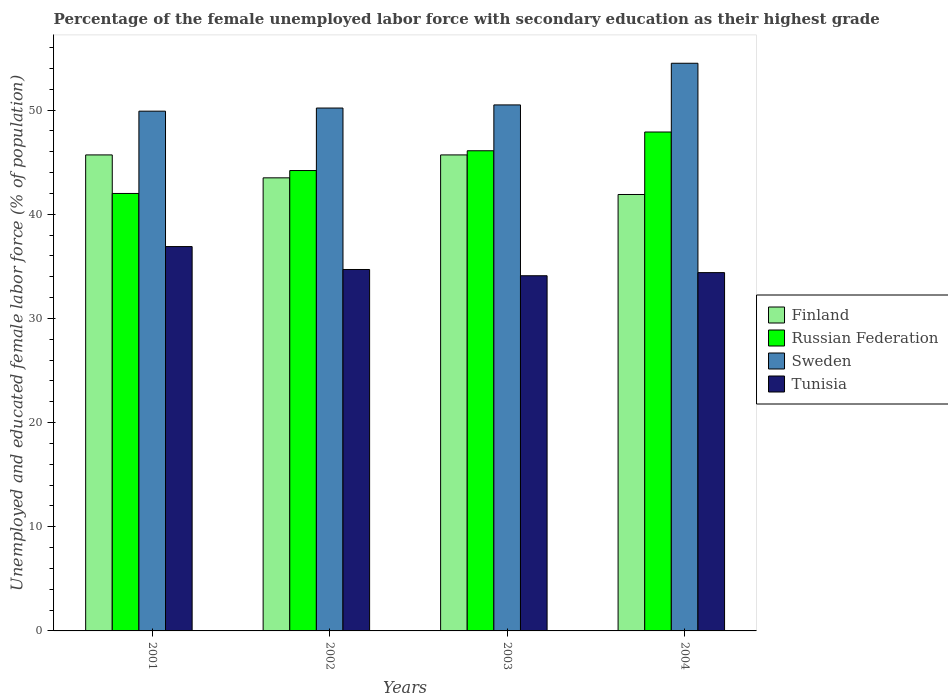How many different coloured bars are there?
Give a very brief answer. 4. How many bars are there on the 2nd tick from the left?
Offer a very short reply. 4. How many bars are there on the 3rd tick from the right?
Your answer should be compact. 4. What is the label of the 1st group of bars from the left?
Your response must be concise. 2001. What is the percentage of the unemployed female labor force with secondary education in Russian Federation in 2004?
Offer a terse response. 47.9. Across all years, what is the maximum percentage of the unemployed female labor force with secondary education in Sweden?
Ensure brevity in your answer.  54.5. Across all years, what is the minimum percentage of the unemployed female labor force with secondary education in Tunisia?
Provide a succinct answer. 34.1. In which year was the percentage of the unemployed female labor force with secondary education in Sweden maximum?
Your answer should be very brief. 2004. What is the total percentage of the unemployed female labor force with secondary education in Finland in the graph?
Make the answer very short. 176.8. What is the difference between the percentage of the unemployed female labor force with secondary education in Sweden in 2001 and that in 2003?
Offer a terse response. -0.6. What is the difference between the percentage of the unemployed female labor force with secondary education in Finland in 2003 and the percentage of the unemployed female labor force with secondary education in Russian Federation in 2004?
Give a very brief answer. -2.2. What is the average percentage of the unemployed female labor force with secondary education in Sweden per year?
Make the answer very short. 51.28. What is the ratio of the percentage of the unemployed female labor force with secondary education in Sweden in 2001 to that in 2004?
Your response must be concise. 0.92. Is the percentage of the unemployed female labor force with secondary education in Tunisia in 2002 less than that in 2004?
Provide a succinct answer. No. Is the difference between the percentage of the unemployed female labor force with secondary education in Russian Federation in 2003 and 2004 greater than the difference between the percentage of the unemployed female labor force with secondary education in Finland in 2003 and 2004?
Provide a succinct answer. No. What is the difference between the highest and the second highest percentage of the unemployed female labor force with secondary education in Russian Federation?
Make the answer very short. 1.8. What is the difference between the highest and the lowest percentage of the unemployed female labor force with secondary education in Tunisia?
Your answer should be compact. 2.8. In how many years, is the percentage of the unemployed female labor force with secondary education in Tunisia greater than the average percentage of the unemployed female labor force with secondary education in Tunisia taken over all years?
Your answer should be compact. 1. Is it the case that in every year, the sum of the percentage of the unemployed female labor force with secondary education in Finland and percentage of the unemployed female labor force with secondary education in Tunisia is greater than the sum of percentage of the unemployed female labor force with secondary education in Sweden and percentage of the unemployed female labor force with secondary education in Russian Federation?
Make the answer very short. No. How many bars are there?
Offer a very short reply. 16. Are all the bars in the graph horizontal?
Your answer should be compact. No. What is the difference between two consecutive major ticks on the Y-axis?
Offer a terse response. 10. Does the graph contain any zero values?
Keep it short and to the point. No. How are the legend labels stacked?
Give a very brief answer. Vertical. What is the title of the graph?
Offer a terse response. Percentage of the female unemployed labor force with secondary education as their highest grade. What is the label or title of the X-axis?
Your response must be concise. Years. What is the label or title of the Y-axis?
Your answer should be compact. Unemployed and educated female labor force (% of population). What is the Unemployed and educated female labor force (% of population) of Finland in 2001?
Give a very brief answer. 45.7. What is the Unemployed and educated female labor force (% of population) of Sweden in 2001?
Offer a very short reply. 49.9. What is the Unemployed and educated female labor force (% of population) in Tunisia in 2001?
Your answer should be very brief. 36.9. What is the Unemployed and educated female labor force (% of population) of Finland in 2002?
Provide a succinct answer. 43.5. What is the Unemployed and educated female labor force (% of population) in Russian Federation in 2002?
Make the answer very short. 44.2. What is the Unemployed and educated female labor force (% of population) in Sweden in 2002?
Offer a very short reply. 50.2. What is the Unemployed and educated female labor force (% of population) of Tunisia in 2002?
Give a very brief answer. 34.7. What is the Unemployed and educated female labor force (% of population) in Finland in 2003?
Your answer should be very brief. 45.7. What is the Unemployed and educated female labor force (% of population) in Russian Federation in 2003?
Your answer should be very brief. 46.1. What is the Unemployed and educated female labor force (% of population) in Sweden in 2003?
Your answer should be very brief. 50.5. What is the Unemployed and educated female labor force (% of population) of Tunisia in 2003?
Provide a succinct answer. 34.1. What is the Unemployed and educated female labor force (% of population) of Finland in 2004?
Provide a short and direct response. 41.9. What is the Unemployed and educated female labor force (% of population) in Russian Federation in 2004?
Keep it short and to the point. 47.9. What is the Unemployed and educated female labor force (% of population) of Sweden in 2004?
Give a very brief answer. 54.5. What is the Unemployed and educated female labor force (% of population) of Tunisia in 2004?
Give a very brief answer. 34.4. Across all years, what is the maximum Unemployed and educated female labor force (% of population) of Finland?
Provide a succinct answer. 45.7. Across all years, what is the maximum Unemployed and educated female labor force (% of population) in Russian Federation?
Your answer should be very brief. 47.9. Across all years, what is the maximum Unemployed and educated female labor force (% of population) of Sweden?
Give a very brief answer. 54.5. Across all years, what is the maximum Unemployed and educated female labor force (% of population) in Tunisia?
Provide a short and direct response. 36.9. Across all years, what is the minimum Unemployed and educated female labor force (% of population) of Finland?
Ensure brevity in your answer.  41.9. Across all years, what is the minimum Unemployed and educated female labor force (% of population) of Russian Federation?
Make the answer very short. 42. Across all years, what is the minimum Unemployed and educated female labor force (% of population) of Sweden?
Offer a very short reply. 49.9. Across all years, what is the minimum Unemployed and educated female labor force (% of population) of Tunisia?
Give a very brief answer. 34.1. What is the total Unemployed and educated female labor force (% of population) of Finland in the graph?
Offer a very short reply. 176.8. What is the total Unemployed and educated female labor force (% of population) in Russian Federation in the graph?
Provide a succinct answer. 180.2. What is the total Unemployed and educated female labor force (% of population) of Sweden in the graph?
Give a very brief answer. 205.1. What is the total Unemployed and educated female labor force (% of population) of Tunisia in the graph?
Ensure brevity in your answer.  140.1. What is the difference between the Unemployed and educated female labor force (% of population) in Finland in 2001 and that in 2002?
Provide a short and direct response. 2.2. What is the difference between the Unemployed and educated female labor force (% of population) of Russian Federation in 2001 and that in 2002?
Offer a very short reply. -2.2. What is the difference between the Unemployed and educated female labor force (% of population) of Finland in 2001 and that in 2003?
Your answer should be compact. 0. What is the difference between the Unemployed and educated female labor force (% of population) of Russian Federation in 2001 and that in 2003?
Your answer should be very brief. -4.1. What is the difference between the Unemployed and educated female labor force (% of population) of Sweden in 2001 and that in 2003?
Provide a short and direct response. -0.6. What is the difference between the Unemployed and educated female labor force (% of population) in Russian Federation in 2001 and that in 2004?
Keep it short and to the point. -5.9. What is the difference between the Unemployed and educated female labor force (% of population) of Sweden in 2001 and that in 2004?
Your answer should be very brief. -4.6. What is the difference between the Unemployed and educated female labor force (% of population) of Tunisia in 2001 and that in 2004?
Give a very brief answer. 2.5. What is the difference between the Unemployed and educated female labor force (% of population) in Finland in 2002 and that in 2003?
Ensure brevity in your answer.  -2.2. What is the difference between the Unemployed and educated female labor force (% of population) of Russian Federation in 2002 and that in 2003?
Give a very brief answer. -1.9. What is the difference between the Unemployed and educated female labor force (% of population) in Russian Federation in 2002 and that in 2004?
Your answer should be very brief. -3.7. What is the difference between the Unemployed and educated female labor force (% of population) in Tunisia in 2002 and that in 2004?
Your answer should be compact. 0.3. What is the difference between the Unemployed and educated female labor force (% of population) of Finland in 2001 and the Unemployed and educated female labor force (% of population) of Russian Federation in 2002?
Provide a short and direct response. 1.5. What is the difference between the Unemployed and educated female labor force (% of population) in Finland in 2001 and the Unemployed and educated female labor force (% of population) in Sweden in 2002?
Provide a short and direct response. -4.5. What is the difference between the Unemployed and educated female labor force (% of population) of Finland in 2001 and the Unemployed and educated female labor force (% of population) of Tunisia in 2002?
Your answer should be very brief. 11. What is the difference between the Unemployed and educated female labor force (% of population) of Russian Federation in 2001 and the Unemployed and educated female labor force (% of population) of Sweden in 2002?
Make the answer very short. -8.2. What is the difference between the Unemployed and educated female labor force (% of population) in Russian Federation in 2001 and the Unemployed and educated female labor force (% of population) in Tunisia in 2002?
Your answer should be very brief. 7.3. What is the difference between the Unemployed and educated female labor force (% of population) of Finland in 2001 and the Unemployed and educated female labor force (% of population) of Sweden in 2003?
Provide a succinct answer. -4.8. What is the difference between the Unemployed and educated female labor force (% of population) in Russian Federation in 2001 and the Unemployed and educated female labor force (% of population) in Sweden in 2003?
Ensure brevity in your answer.  -8.5. What is the difference between the Unemployed and educated female labor force (% of population) in Russian Federation in 2001 and the Unemployed and educated female labor force (% of population) in Tunisia in 2003?
Your response must be concise. 7.9. What is the difference between the Unemployed and educated female labor force (% of population) in Sweden in 2001 and the Unemployed and educated female labor force (% of population) in Tunisia in 2003?
Your answer should be compact. 15.8. What is the difference between the Unemployed and educated female labor force (% of population) in Finland in 2001 and the Unemployed and educated female labor force (% of population) in Sweden in 2004?
Ensure brevity in your answer.  -8.8. What is the difference between the Unemployed and educated female labor force (% of population) of Finland in 2001 and the Unemployed and educated female labor force (% of population) of Tunisia in 2004?
Your answer should be compact. 11.3. What is the difference between the Unemployed and educated female labor force (% of population) of Finland in 2002 and the Unemployed and educated female labor force (% of population) of Tunisia in 2003?
Ensure brevity in your answer.  9.4. What is the difference between the Unemployed and educated female labor force (% of population) in Russian Federation in 2002 and the Unemployed and educated female labor force (% of population) in Sweden in 2003?
Ensure brevity in your answer.  -6.3. What is the difference between the Unemployed and educated female labor force (% of population) of Russian Federation in 2002 and the Unemployed and educated female labor force (% of population) of Tunisia in 2003?
Make the answer very short. 10.1. What is the difference between the Unemployed and educated female labor force (% of population) in Sweden in 2002 and the Unemployed and educated female labor force (% of population) in Tunisia in 2003?
Your answer should be very brief. 16.1. What is the difference between the Unemployed and educated female labor force (% of population) of Finland in 2002 and the Unemployed and educated female labor force (% of population) of Sweden in 2004?
Your answer should be very brief. -11. What is the difference between the Unemployed and educated female labor force (% of population) in Finland in 2002 and the Unemployed and educated female labor force (% of population) in Tunisia in 2004?
Provide a succinct answer. 9.1. What is the difference between the Unemployed and educated female labor force (% of population) in Russian Federation in 2002 and the Unemployed and educated female labor force (% of population) in Sweden in 2004?
Offer a terse response. -10.3. What is the difference between the Unemployed and educated female labor force (% of population) of Sweden in 2002 and the Unemployed and educated female labor force (% of population) of Tunisia in 2004?
Offer a very short reply. 15.8. What is the difference between the Unemployed and educated female labor force (% of population) of Finland in 2003 and the Unemployed and educated female labor force (% of population) of Tunisia in 2004?
Provide a short and direct response. 11.3. What is the average Unemployed and educated female labor force (% of population) in Finland per year?
Ensure brevity in your answer.  44.2. What is the average Unemployed and educated female labor force (% of population) in Russian Federation per year?
Offer a terse response. 45.05. What is the average Unemployed and educated female labor force (% of population) of Sweden per year?
Give a very brief answer. 51.27. What is the average Unemployed and educated female labor force (% of population) of Tunisia per year?
Your answer should be compact. 35.02. In the year 2001, what is the difference between the Unemployed and educated female labor force (% of population) in Finland and Unemployed and educated female labor force (% of population) in Russian Federation?
Your answer should be very brief. 3.7. In the year 2001, what is the difference between the Unemployed and educated female labor force (% of population) of Finland and Unemployed and educated female labor force (% of population) of Tunisia?
Your answer should be compact. 8.8. In the year 2001, what is the difference between the Unemployed and educated female labor force (% of population) of Russian Federation and Unemployed and educated female labor force (% of population) of Tunisia?
Your answer should be very brief. 5.1. In the year 2002, what is the difference between the Unemployed and educated female labor force (% of population) in Finland and Unemployed and educated female labor force (% of population) in Russian Federation?
Provide a short and direct response. -0.7. In the year 2002, what is the difference between the Unemployed and educated female labor force (% of population) in Finland and Unemployed and educated female labor force (% of population) in Sweden?
Provide a succinct answer. -6.7. In the year 2002, what is the difference between the Unemployed and educated female labor force (% of population) of Russian Federation and Unemployed and educated female labor force (% of population) of Tunisia?
Offer a very short reply. 9.5. In the year 2003, what is the difference between the Unemployed and educated female labor force (% of population) in Finland and Unemployed and educated female labor force (% of population) in Russian Federation?
Provide a succinct answer. -0.4. In the year 2003, what is the difference between the Unemployed and educated female labor force (% of population) in Finland and Unemployed and educated female labor force (% of population) in Sweden?
Give a very brief answer. -4.8. In the year 2003, what is the difference between the Unemployed and educated female labor force (% of population) in Finland and Unemployed and educated female labor force (% of population) in Tunisia?
Provide a succinct answer. 11.6. In the year 2003, what is the difference between the Unemployed and educated female labor force (% of population) of Russian Federation and Unemployed and educated female labor force (% of population) of Sweden?
Offer a terse response. -4.4. In the year 2004, what is the difference between the Unemployed and educated female labor force (% of population) of Finland and Unemployed and educated female labor force (% of population) of Russian Federation?
Your answer should be compact. -6. In the year 2004, what is the difference between the Unemployed and educated female labor force (% of population) in Finland and Unemployed and educated female labor force (% of population) in Sweden?
Make the answer very short. -12.6. In the year 2004, what is the difference between the Unemployed and educated female labor force (% of population) in Finland and Unemployed and educated female labor force (% of population) in Tunisia?
Provide a short and direct response. 7.5. In the year 2004, what is the difference between the Unemployed and educated female labor force (% of population) in Russian Federation and Unemployed and educated female labor force (% of population) in Tunisia?
Your answer should be very brief. 13.5. In the year 2004, what is the difference between the Unemployed and educated female labor force (% of population) of Sweden and Unemployed and educated female labor force (% of population) of Tunisia?
Your response must be concise. 20.1. What is the ratio of the Unemployed and educated female labor force (% of population) in Finland in 2001 to that in 2002?
Make the answer very short. 1.05. What is the ratio of the Unemployed and educated female labor force (% of population) of Russian Federation in 2001 to that in 2002?
Offer a terse response. 0.95. What is the ratio of the Unemployed and educated female labor force (% of population) in Tunisia in 2001 to that in 2002?
Ensure brevity in your answer.  1.06. What is the ratio of the Unemployed and educated female labor force (% of population) of Finland in 2001 to that in 2003?
Your answer should be compact. 1. What is the ratio of the Unemployed and educated female labor force (% of population) in Russian Federation in 2001 to that in 2003?
Ensure brevity in your answer.  0.91. What is the ratio of the Unemployed and educated female labor force (% of population) of Sweden in 2001 to that in 2003?
Keep it short and to the point. 0.99. What is the ratio of the Unemployed and educated female labor force (% of population) in Tunisia in 2001 to that in 2003?
Your answer should be very brief. 1.08. What is the ratio of the Unemployed and educated female labor force (% of population) in Finland in 2001 to that in 2004?
Offer a very short reply. 1.09. What is the ratio of the Unemployed and educated female labor force (% of population) of Russian Federation in 2001 to that in 2004?
Your response must be concise. 0.88. What is the ratio of the Unemployed and educated female labor force (% of population) in Sweden in 2001 to that in 2004?
Provide a succinct answer. 0.92. What is the ratio of the Unemployed and educated female labor force (% of population) of Tunisia in 2001 to that in 2004?
Provide a short and direct response. 1.07. What is the ratio of the Unemployed and educated female labor force (% of population) in Finland in 2002 to that in 2003?
Keep it short and to the point. 0.95. What is the ratio of the Unemployed and educated female labor force (% of population) of Russian Federation in 2002 to that in 2003?
Offer a very short reply. 0.96. What is the ratio of the Unemployed and educated female labor force (% of population) of Tunisia in 2002 to that in 2003?
Your response must be concise. 1.02. What is the ratio of the Unemployed and educated female labor force (% of population) in Finland in 2002 to that in 2004?
Offer a terse response. 1.04. What is the ratio of the Unemployed and educated female labor force (% of population) in Russian Federation in 2002 to that in 2004?
Provide a succinct answer. 0.92. What is the ratio of the Unemployed and educated female labor force (% of population) of Sweden in 2002 to that in 2004?
Give a very brief answer. 0.92. What is the ratio of the Unemployed and educated female labor force (% of population) in Tunisia in 2002 to that in 2004?
Your response must be concise. 1.01. What is the ratio of the Unemployed and educated female labor force (% of population) in Finland in 2003 to that in 2004?
Keep it short and to the point. 1.09. What is the ratio of the Unemployed and educated female labor force (% of population) of Russian Federation in 2003 to that in 2004?
Ensure brevity in your answer.  0.96. What is the ratio of the Unemployed and educated female labor force (% of population) of Sweden in 2003 to that in 2004?
Offer a terse response. 0.93. What is the ratio of the Unemployed and educated female labor force (% of population) of Tunisia in 2003 to that in 2004?
Your response must be concise. 0.99. What is the difference between the highest and the second highest Unemployed and educated female labor force (% of population) in Finland?
Your answer should be compact. 0. What is the difference between the highest and the second highest Unemployed and educated female labor force (% of population) in Sweden?
Offer a terse response. 4. What is the difference between the highest and the second highest Unemployed and educated female labor force (% of population) of Tunisia?
Offer a very short reply. 2.2. What is the difference between the highest and the lowest Unemployed and educated female labor force (% of population) of Finland?
Make the answer very short. 3.8. 